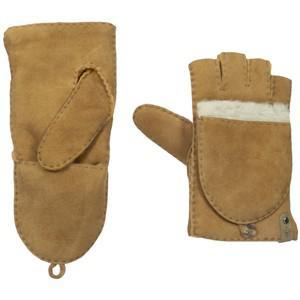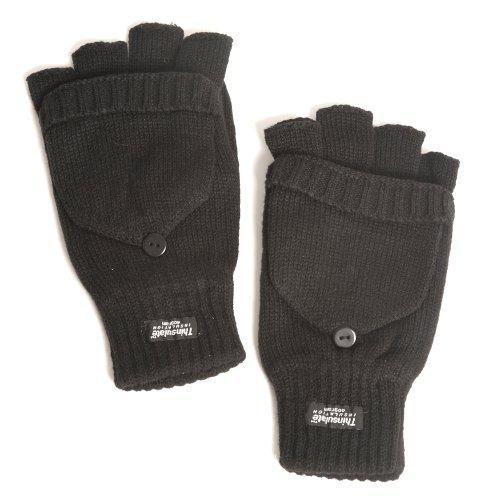The first image is the image on the left, the second image is the image on the right. Considering the images on both sides, is "Two mittens are shown covered." valid? Answer yes or no. No. The first image is the image on the left, the second image is the image on the right. For the images displayed, is the sentence "The gloves are made of a knitted material." factually correct? Answer yes or no. No. 